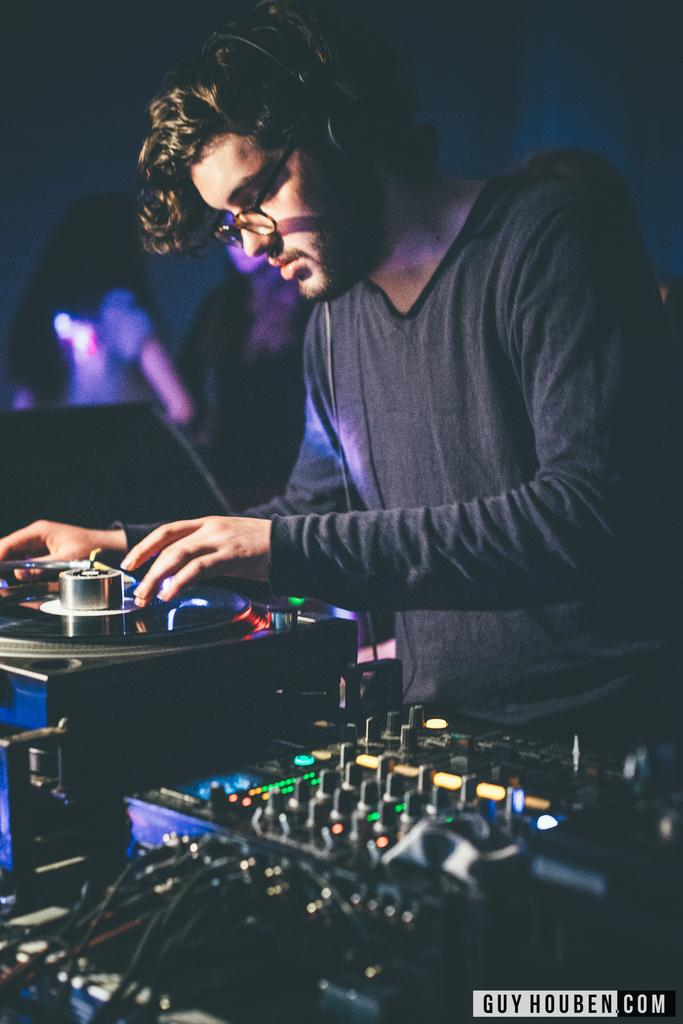What type of objects are located at the bottom of the image? There are electronic devices at the bottom of the image. Can you identify any specific electronic device among them? Yes, a music player is present among the electronic devices. What is the man in the image doing? The man is standing at the music player. How would you describe the overall appearance of the background in the image? The background of the image is dark and blurry. Are there any other people visible in the image besides the man at the music player? Yes, there are a few persons visible in the background. What type of plastic material can be seen in the alley in the image? There is no alley or plastic material present in the image. What observation can be made about the man's behavior in the image? The image does not provide enough information to make any observations about the man's behavior. 